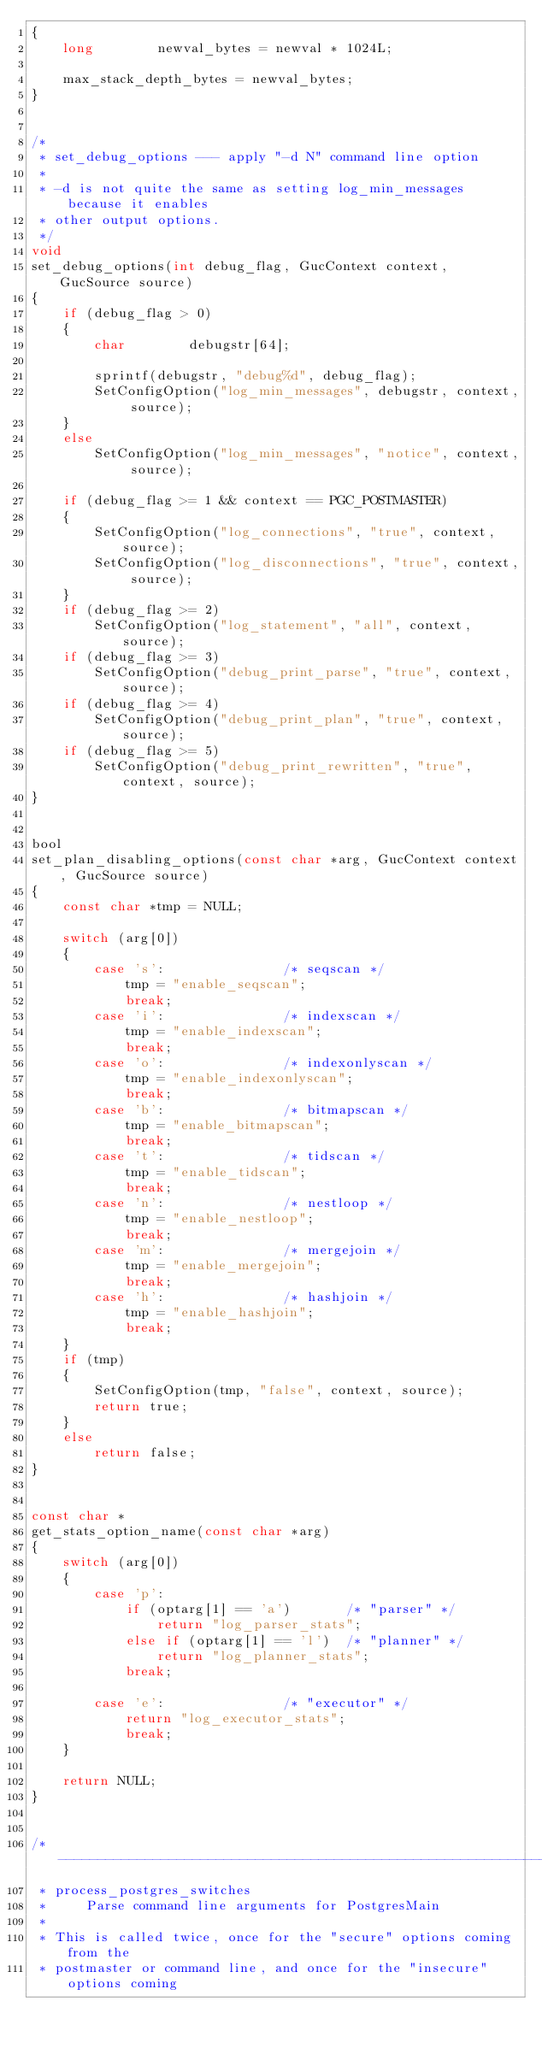<code> <loc_0><loc_0><loc_500><loc_500><_C_>{
	long		newval_bytes = newval * 1024L;

	max_stack_depth_bytes = newval_bytes;
}


/*
 * set_debug_options --- apply "-d N" command line option
 *
 * -d is not quite the same as setting log_min_messages because it enables
 * other output options.
 */
void
set_debug_options(int debug_flag, GucContext context, GucSource source)
{
	if (debug_flag > 0)
	{
		char		debugstr[64];

		sprintf(debugstr, "debug%d", debug_flag);
		SetConfigOption("log_min_messages", debugstr, context, source);
	}
	else
		SetConfigOption("log_min_messages", "notice", context, source);

	if (debug_flag >= 1 && context == PGC_POSTMASTER)
	{
		SetConfigOption("log_connections", "true", context, source);
		SetConfigOption("log_disconnections", "true", context, source);
	}
	if (debug_flag >= 2)
		SetConfigOption("log_statement", "all", context, source);
	if (debug_flag >= 3)
		SetConfigOption("debug_print_parse", "true", context, source);
	if (debug_flag >= 4)
		SetConfigOption("debug_print_plan", "true", context, source);
	if (debug_flag >= 5)
		SetConfigOption("debug_print_rewritten", "true", context, source);
}


bool
set_plan_disabling_options(const char *arg, GucContext context, GucSource source)
{
	const char *tmp = NULL;

	switch (arg[0])
	{
		case 's':				/* seqscan */
			tmp = "enable_seqscan";
			break;
		case 'i':				/* indexscan */
			tmp = "enable_indexscan";
			break;
		case 'o':				/* indexonlyscan */
			tmp = "enable_indexonlyscan";
			break;
		case 'b':				/* bitmapscan */
			tmp = "enable_bitmapscan";
			break;
		case 't':				/* tidscan */
			tmp = "enable_tidscan";
			break;
		case 'n':				/* nestloop */
			tmp = "enable_nestloop";
			break;
		case 'm':				/* mergejoin */
			tmp = "enable_mergejoin";
			break;
		case 'h':				/* hashjoin */
			tmp = "enable_hashjoin";
			break;
	}
	if (tmp)
	{
		SetConfigOption(tmp, "false", context, source);
		return true;
	}
	else
		return false;
}


const char *
get_stats_option_name(const char *arg)
{
	switch (arg[0])
	{
		case 'p':
			if (optarg[1] == 'a')		/* "parser" */
				return "log_parser_stats";
			else if (optarg[1] == 'l')	/* "planner" */
				return "log_planner_stats";
			break;

		case 'e':				/* "executor" */
			return "log_executor_stats";
			break;
	}

	return NULL;
}


/* ----------------------------------------------------------------
 * process_postgres_switches
 *	   Parse command line arguments for PostgresMain
 *
 * This is called twice, once for the "secure" options coming from the
 * postmaster or command line, and once for the "insecure" options coming</code> 